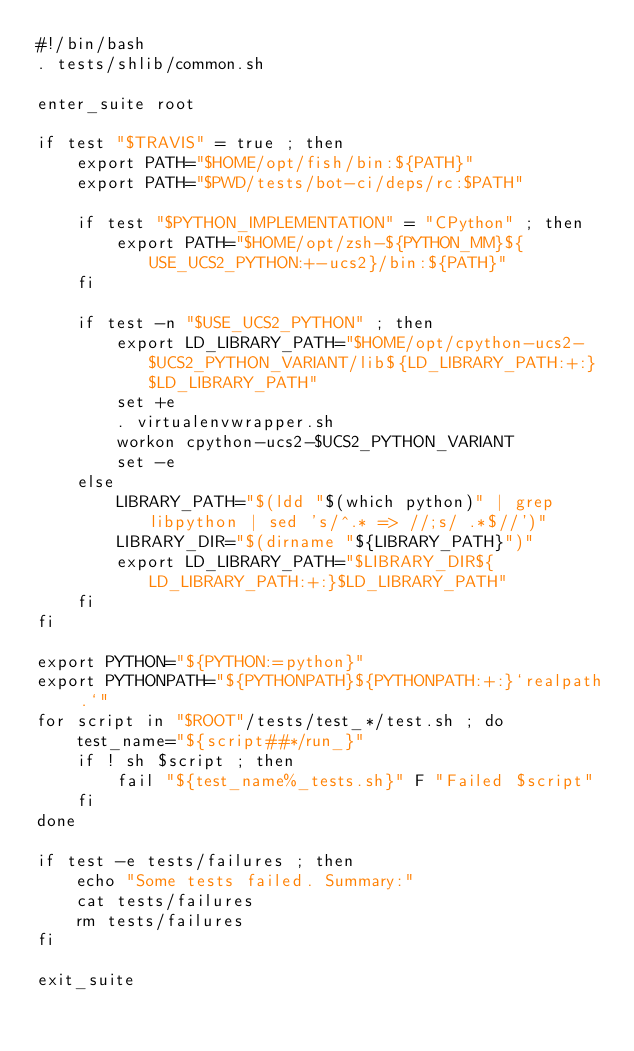Convert code to text. <code><loc_0><loc_0><loc_500><loc_500><_Bash_>#!/bin/bash
. tests/shlib/common.sh

enter_suite root

if test "$TRAVIS" = true ; then
	export PATH="$HOME/opt/fish/bin:${PATH}"
	export PATH="$PWD/tests/bot-ci/deps/rc:$PATH"

	if test "$PYTHON_IMPLEMENTATION" = "CPython" ; then
		export PATH="$HOME/opt/zsh-${PYTHON_MM}${USE_UCS2_PYTHON:+-ucs2}/bin:${PATH}"
	fi

	if test -n "$USE_UCS2_PYTHON" ; then
		export LD_LIBRARY_PATH="$HOME/opt/cpython-ucs2-$UCS2_PYTHON_VARIANT/lib${LD_LIBRARY_PATH:+:}$LD_LIBRARY_PATH"
		set +e
		. virtualenvwrapper.sh
		workon cpython-ucs2-$UCS2_PYTHON_VARIANT
		set -e
	else
		LIBRARY_PATH="$(ldd "$(which python)" | grep libpython | sed 's/^.* => //;s/ .*$//')"
		LIBRARY_DIR="$(dirname "${LIBRARY_PATH}")"
		export LD_LIBRARY_PATH="$LIBRARY_DIR${LD_LIBRARY_PATH:+:}$LD_LIBRARY_PATH"
	fi
fi

export PYTHON="${PYTHON:=python}"
export PYTHONPATH="${PYTHONPATH}${PYTHONPATH:+:}`realpath .`"
for script in "$ROOT"/tests/test_*/test.sh ; do
	test_name="${script##*/run_}"
	if ! sh $script ; then
		fail "${test_name%_tests.sh}" F "Failed $script"
	fi
done

if test -e tests/failures ; then
	echo "Some tests failed. Summary:"
	cat tests/failures
	rm tests/failures
fi

exit_suite
</code> 